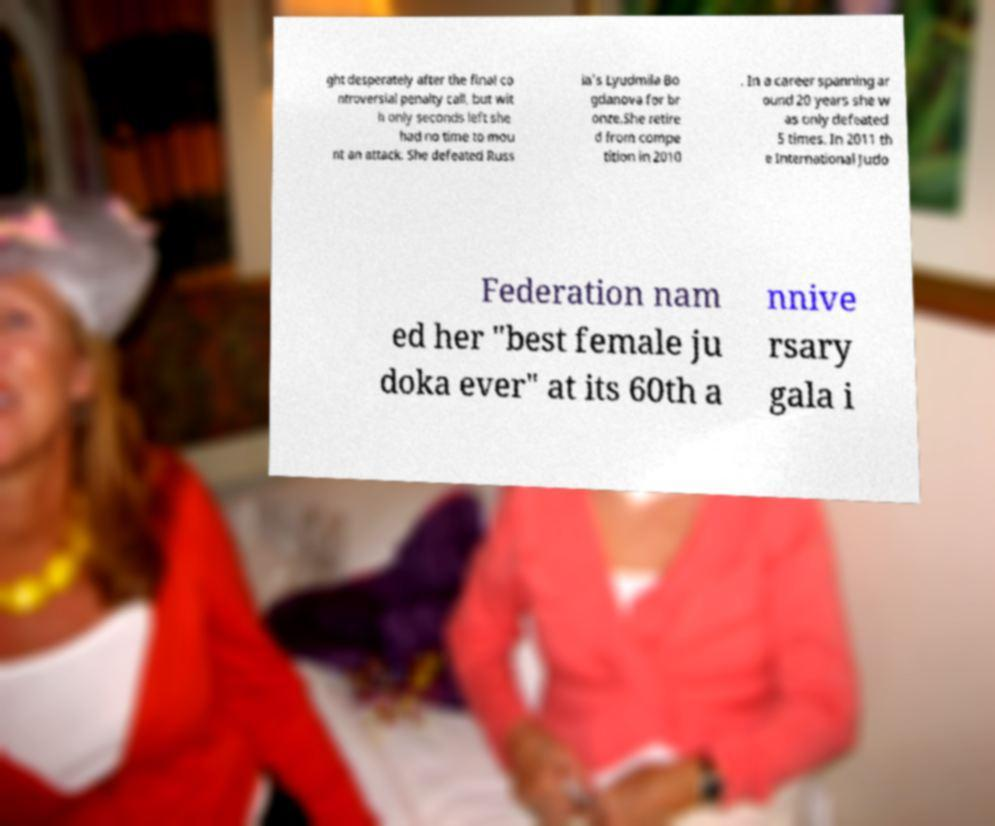Could you extract and type out the text from this image? ght desperately after the final co ntroversial penalty call, but wit h only seconds left she had no time to mou nt an attack. She defeated Russ ia's Lyudmila Bo gdanova for br onze.She retire d from compe tition in 2010 . In a career spanning ar ound 20 years she w as only defeated 5 times. In 2011 th e International Judo Federation nam ed her "best female ju doka ever" at its 60th a nnive rsary gala i 